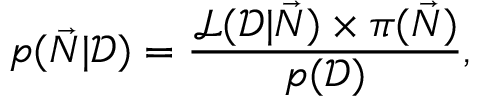Convert formula to latex. <formula><loc_0><loc_0><loc_500><loc_500>p ( \vec { N } | \mathcal { D } ) = \frac { \mathcal { L } ( \mathcal { D } | \vec { N } ) \times \pi ( \vec { N } ) } { p ( \mathcal { D } ) } ,</formula> 